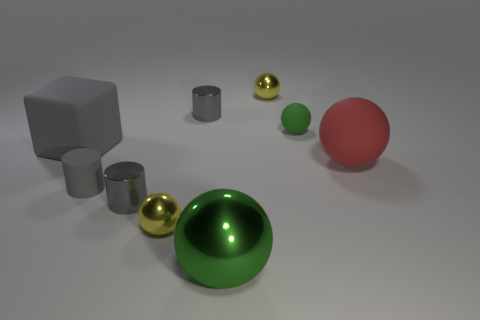Are there more green spheres than large purple shiny blocks?
Provide a succinct answer. Yes. What material is the red sphere?
Ensure brevity in your answer.  Rubber. What number of other things are there of the same material as the large gray thing
Make the answer very short. 3. How many green balls are there?
Offer a very short reply. 2. There is a tiny green thing that is the same shape as the red thing; what is its material?
Offer a very short reply. Rubber. Is the green ball that is behind the red rubber thing made of the same material as the big green thing?
Provide a short and direct response. No. Are there more cylinders behind the big red sphere than big rubber blocks behind the green matte object?
Ensure brevity in your answer.  Yes. How big is the rubber cylinder?
Offer a very short reply. Small. What shape is the other gray thing that is the same material as the large gray object?
Your answer should be compact. Cylinder. Do the small yellow shiny object left of the large green object and the large red rubber thing have the same shape?
Your response must be concise. Yes. 